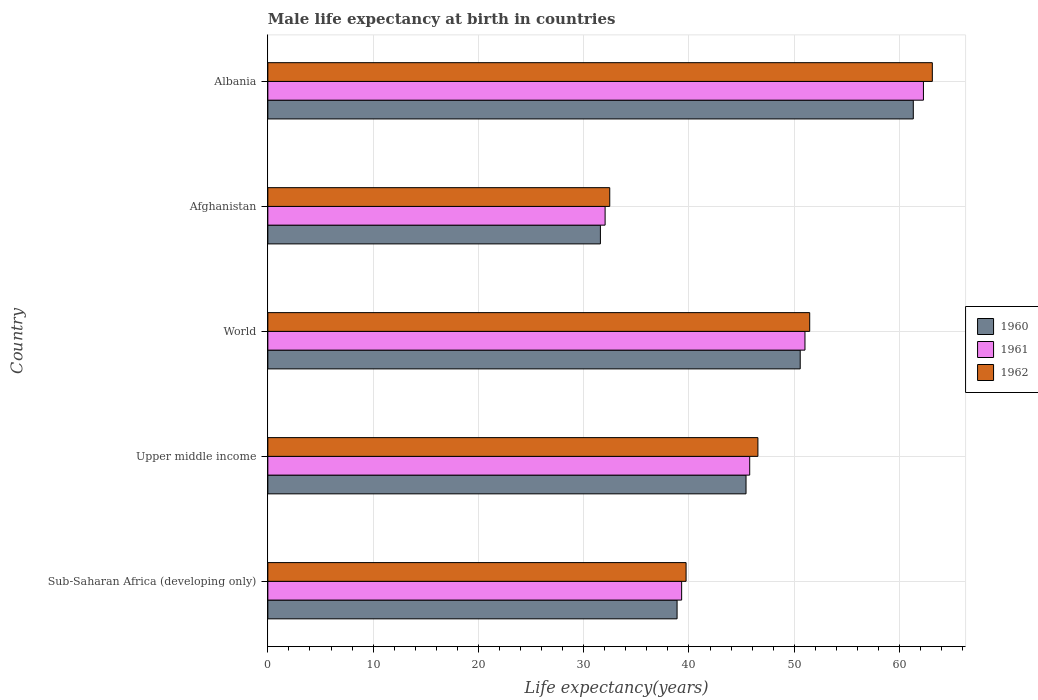How many groups of bars are there?
Your response must be concise. 5. Are the number of bars per tick equal to the number of legend labels?
Keep it short and to the point. Yes. Are the number of bars on each tick of the Y-axis equal?
Your answer should be very brief. Yes. What is the label of the 2nd group of bars from the top?
Your answer should be compact. Afghanistan. In how many cases, is the number of bars for a given country not equal to the number of legend labels?
Make the answer very short. 0. What is the male life expectancy at birth in 1962 in World?
Provide a short and direct response. 51.47. Across all countries, what is the maximum male life expectancy at birth in 1962?
Provide a succinct answer. 63.12. Across all countries, what is the minimum male life expectancy at birth in 1962?
Offer a very short reply. 32.48. In which country was the male life expectancy at birth in 1960 maximum?
Offer a terse response. Albania. In which country was the male life expectancy at birth in 1961 minimum?
Offer a terse response. Afghanistan. What is the total male life expectancy at birth in 1961 in the graph?
Make the answer very short. 230.4. What is the difference between the male life expectancy at birth in 1962 in Afghanistan and that in Upper middle income?
Keep it short and to the point. -14.07. What is the difference between the male life expectancy at birth in 1960 in Albania and the male life expectancy at birth in 1961 in Sub-Saharan Africa (developing only)?
Your response must be concise. 22. What is the average male life expectancy at birth in 1960 per country?
Your response must be concise. 45.55. What is the difference between the male life expectancy at birth in 1961 and male life expectancy at birth in 1962 in World?
Ensure brevity in your answer.  -0.45. In how many countries, is the male life expectancy at birth in 1961 greater than 22 years?
Ensure brevity in your answer.  5. What is the ratio of the male life expectancy at birth in 1962 in Afghanistan to that in World?
Give a very brief answer. 0.63. What is the difference between the highest and the second highest male life expectancy at birth in 1960?
Offer a terse response. 10.74. What is the difference between the highest and the lowest male life expectancy at birth in 1962?
Ensure brevity in your answer.  30.64. What does the 3rd bar from the top in World represents?
Keep it short and to the point. 1960. Are all the bars in the graph horizontal?
Your response must be concise. Yes. How many countries are there in the graph?
Make the answer very short. 5. Are the values on the major ticks of X-axis written in scientific E-notation?
Make the answer very short. No. Does the graph contain grids?
Your answer should be very brief. Yes. Where does the legend appear in the graph?
Make the answer very short. Center right. How are the legend labels stacked?
Your answer should be very brief. Vertical. What is the title of the graph?
Your response must be concise. Male life expectancy at birth in countries. Does "1980" appear as one of the legend labels in the graph?
Your response must be concise. No. What is the label or title of the X-axis?
Your answer should be very brief. Life expectancy(years). What is the Life expectancy(years) in 1960 in Sub-Saharan Africa (developing only)?
Provide a succinct answer. 38.87. What is the Life expectancy(years) of 1961 in Sub-Saharan Africa (developing only)?
Ensure brevity in your answer.  39.31. What is the Life expectancy(years) in 1962 in Sub-Saharan Africa (developing only)?
Offer a very short reply. 39.73. What is the Life expectancy(years) in 1960 in Upper middle income?
Your answer should be very brief. 45.42. What is the Life expectancy(years) of 1961 in Upper middle income?
Ensure brevity in your answer.  45.77. What is the Life expectancy(years) of 1962 in Upper middle income?
Ensure brevity in your answer.  46.55. What is the Life expectancy(years) in 1960 in World?
Your answer should be compact. 50.57. What is the Life expectancy(years) of 1961 in World?
Offer a terse response. 51.02. What is the Life expectancy(years) in 1962 in World?
Your answer should be compact. 51.47. What is the Life expectancy(years) of 1960 in Afghanistan?
Your answer should be compact. 31.59. What is the Life expectancy(years) of 1961 in Afghanistan?
Your answer should be very brief. 32.03. What is the Life expectancy(years) of 1962 in Afghanistan?
Keep it short and to the point. 32.48. What is the Life expectancy(years) of 1960 in Albania?
Give a very brief answer. 61.31. What is the Life expectancy(years) of 1961 in Albania?
Give a very brief answer. 62.27. What is the Life expectancy(years) of 1962 in Albania?
Provide a succinct answer. 63.12. Across all countries, what is the maximum Life expectancy(years) of 1960?
Your response must be concise. 61.31. Across all countries, what is the maximum Life expectancy(years) in 1961?
Your answer should be very brief. 62.27. Across all countries, what is the maximum Life expectancy(years) of 1962?
Offer a terse response. 63.12. Across all countries, what is the minimum Life expectancy(years) in 1960?
Offer a very short reply. 31.59. Across all countries, what is the minimum Life expectancy(years) in 1961?
Your response must be concise. 32.03. Across all countries, what is the minimum Life expectancy(years) in 1962?
Provide a succinct answer. 32.48. What is the total Life expectancy(years) of 1960 in the graph?
Your answer should be very brief. 227.76. What is the total Life expectancy(years) in 1961 in the graph?
Ensure brevity in your answer.  230.4. What is the total Life expectancy(years) of 1962 in the graph?
Provide a succinct answer. 233.34. What is the difference between the Life expectancy(years) in 1960 in Sub-Saharan Africa (developing only) and that in Upper middle income?
Your response must be concise. -6.55. What is the difference between the Life expectancy(years) of 1961 in Sub-Saharan Africa (developing only) and that in Upper middle income?
Your answer should be very brief. -6.47. What is the difference between the Life expectancy(years) of 1962 in Sub-Saharan Africa (developing only) and that in Upper middle income?
Make the answer very short. -6.82. What is the difference between the Life expectancy(years) of 1960 in Sub-Saharan Africa (developing only) and that in World?
Make the answer very short. -11.7. What is the difference between the Life expectancy(years) of 1961 in Sub-Saharan Africa (developing only) and that in World?
Offer a terse response. -11.71. What is the difference between the Life expectancy(years) in 1962 in Sub-Saharan Africa (developing only) and that in World?
Offer a very short reply. -11.74. What is the difference between the Life expectancy(years) in 1960 in Sub-Saharan Africa (developing only) and that in Afghanistan?
Your answer should be compact. 7.28. What is the difference between the Life expectancy(years) of 1961 in Sub-Saharan Africa (developing only) and that in Afghanistan?
Provide a succinct answer. 7.27. What is the difference between the Life expectancy(years) of 1962 in Sub-Saharan Africa (developing only) and that in Afghanistan?
Offer a terse response. 7.25. What is the difference between the Life expectancy(years) in 1960 in Sub-Saharan Africa (developing only) and that in Albania?
Ensure brevity in your answer.  -22.44. What is the difference between the Life expectancy(years) of 1961 in Sub-Saharan Africa (developing only) and that in Albania?
Your answer should be very brief. -22.97. What is the difference between the Life expectancy(years) of 1962 in Sub-Saharan Africa (developing only) and that in Albania?
Make the answer very short. -23.39. What is the difference between the Life expectancy(years) of 1960 in Upper middle income and that in World?
Ensure brevity in your answer.  -5.15. What is the difference between the Life expectancy(years) in 1961 in Upper middle income and that in World?
Your response must be concise. -5.25. What is the difference between the Life expectancy(years) in 1962 in Upper middle income and that in World?
Offer a very short reply. -4.92. What is the difference between the Life expectancy(years) of 1960 in Upper middle income and that in Afghanistan?
Offer a terse response. 13.83. What is the difference between the Life expectancy(years) in 1961 in Upper middle income and that in Afghanistan?
Offer a terse response. 13.74. What is the difference between the Life expectancy(years) in 1962 in Upper middle income and that in Afghanistan?
Your answer should be very brief. 14.07. What is the difference between the Life expectancy(years) in 1960 in Upper middle income and that in Albania?
Give a very brief answer. -15.89. What is the difference between the Life expectancy(years) of 1961 in Upper middle income and that in Albania?
Provide a succinct answer. -16.5. What is the difference between the Life expectancy(years) in 1962 in Upper middle income and that in Albania?
Offer a terse response. -16.57. What is the difference between the Life expectancy(years) in 1960 in World and that in Afghanistan?
Keep it short and to the point. 18.98. What is the difference between the Life expectancy(years) in 1961 in World and that in Afghanistan?
Provide a short and direct response. 18.98. What is the difference between the Life expectancy(years) of 1962 in World and that in Afghanistan?
Your response must be concise. 18.99. What is the difference between the Life expectancy(years) in 1960 in World and that in Albania?
Offer a terse response. -10.74. What is the difference between the Life expectancy(years) in 1961 in World and that in Albania?
Your answer should be very brief. -11.25. What is the difference between the Life expectancy(years) in 1962 in World and that in Albania?
Offer a terse response. -11.65. What is the difference between the Life expectancy(years) of 1960 in Afghanistan and that in Albania?
Provide a short and direct response. -29.72. What is the difference between the Life expectancy(years) in 1961 in Afghanistan and that in Albania?
Your answer should be very brief. -30.24. What is the difference between the Life expectancy(years) in 1962 in Afghanistan and that in Albania?
Ensure brevity in your answer.  -30.64. What is the difference between the Life expectancy(years) of 1960 in Sub-Saharan Africa (developing only) and the Life expectancy(years) of 1961 in Upper middle income?
Keep it short and to the point. -6.9. What is the difference between the Life expectancy(years) of 1960 in Sub-Saharan Africa (developing only) and the Life expectancy(years) of 1962 in Upper middle income?
Keep it short and to the point. -7.68. What is the difference between the Life expectancy(years) of 1961 in Sub-Saharan Africa (developing only) and the Life expectancy(years) of 1962 in Upper middle income?
Your response must be concise. -7.24. What is the difference between the Life expectancy(years) in 1960 in Sub-Saharan Africa (developing only) and the Life expectancy(years) in 1961 in World?
Offer a very short reply. -12.15. What is the difference between the Life expectancy(years) of 1960 in Sub-Saharan Africa (developing only) and the Life expectancy(years) of 1962 in World?
Provide a succinct answer. -12.6. What is the difference between the Life expectancy(years) in 1961 in Sub-Saharan Africa (developing only) and the Life expectancy(years) in 1962 in World?
Provide a short and direct response. -12.16. What is the difference between the Life expectancy(years) in 1960 in Sub-Saharan Africa (developing only) and the Life expectancy(years) in 1961 in Afghanistan?
Your answer should be compact. 6.84. What is the difference between the Life expectancy(years) of 1960 in Sub-Saharan Africa (developing only) and the Life expectancy(years) of 1962 in Afghanistan?
Offer a terse response. 6.4. What is the difference between the Life expectancy(years) of 1961 in Sub-Saharan Africa (developing only) and the Life expectancy(years) of 1962 in Afghanistan?
Your response must be concise. 6.83. What is the difference between the Life expectancy(years) of 1960 in Sub-Saharan Africa (developing only) and the Life expectancy(years) of 1961 in Albania?
Provide a succinct answer. -23.4. What is the difference between the Life expectancy(years) of 1960 in Sub-Saharan Africa (developing only) and the Life expectancy(years) of 1962 in Albania?
Your response must be concise. -24.25. What is the difference between the Life expectancy(years) in 1961 in Sub-Saharan Africa (developing only) and the Life expectancy(years) in 1962 in Albania?
Your answer should be compact. -23.81. What is the difference between the Life expectancy(years) of 1960 in Upper middle income and the Life expectancy(years) of 1961 in World?
Provide a succinct answer. -5.6. What is the difference between the Life expectancy(years) in 1960 in Upper middle income and the Life expectancy(years) in 1962 in World?
Your response must be concise. -6.05. What is the difference between the Life expectancy(years) of 1961 in Upper middle income and the Life expectancy(years) of 1962 in World?
Keep it short and to the point. -5.7. What is the difference between the Life expectancy(years) in 1960 in Upper middle income and the Life expectancy(years) in 1961 in Afghanistan?
Offer a terse response. 13.39. What is the difference between the Life expectancy(years) in 1960 in Upper middle income and the Life expectancy(years) in 1962 in Afghanistan?
Ensure brevity in your answer.  12.94. What is the difference between the Life expectancy(years) of 1961 in Upper middle income and the Life expectancy(years) of 1962 in Afghanistan?
Offer a terse response. 13.29. What is the difference between the Life expectancy(years) of 1960 in Upper middle income and the Life expectancy(years) of 1961 in Albania?
Ensure brevity in your answer.  -16.85. What is the difference between the Life expectancy(years) in 1960 in Upper middle income and the Life expectancy(years) in 1962 in Albania?
Your response must be concise. -17.7. What is the difference between the Life expectancy(years) in 1961 in Upper middle income and the Life expectancy(years) in 1962 in Albania?
Your answer should be compact. -17.35. What is the difference between the Life expectancy(years) of 1960 in World and the Life expectancy(years) of 1961 in Afghanistan?
Provide a short and direct response. 18.53. What is the difference between the Life expectancy(years) of 1960 in World and the Life expectancy(years) of 1962 in Afghanistan?
Give a very brief answer. 18.09. What is the difference between the Life expectancy(years) of 1961 in World and the Life expectancy(years) of 1962 in Afghanistan?
Your answer should be very brief. 18.54. What is the difference between the Life expectancy(years) in 1960 in World and the Life expectancy(years) in 1961 in Albania?
Keep it short and to the point. -11.7. What is the difference between the Life expectancy(years) of 1960 in World and the Life expectancy(years) of 1962 in Albania?
Give a very brief answer. -12.55. What is the difference between the Life expectancy(years) in 1961 in World and the Life expectancy(years) in 1962 in Albania?
Your answer should be compact. -12.1. What is the difference between the Life expectancy(years) in 1960 in Afghanistan and the Life expectancy(years) in 1961 in Albania?
Offer a very short reply. -30.68. What is the difference between the Life expectancy(years) in 1960 in Afghanistan and the Life expectancy(years) in 1962 in Albania?
Provide a succinct answer. -31.53. What is the difference between the Life expectancy(years) in 1961 in Afghanistan and the Life expectancy(years) in 1962 in Albania?
Your answer should be compact. -31.08. What is the average Life expectancy(years) of 1960 per country?
Your answer should be compact. 45.55. What is the average Life expectancy(years) of 1961 per country?
Offer a very short reply. 46.08. What is the average Life expectancy(years) of 1962 per country?
Provide a succinct answer. 46.67. What is the difference between the Life expectancy(years) in 1960 and Life expectancy(years) in 1961 in Sub-Saharan Africa (developing only)?
Keep it short and to the point. -0.43. What is the difference between the Life expectancy(years) in 1960 and Life expectancy(years) in 1962 in Sub-Saharan Africa (developing only)?
Your response must be concise. -0.86. What is the difference between the Life expectancy(years) in 1961 and Life expectancy(years) in 1962 in Sub-Saharan Africa (developing only)?
Your answer should be compact. -0.42. What is the difference between the Life expectancy(years) of 1960 and Life expectancy(years) of 1961 in Upper middle income?
Your answer should be very brief. -0.35. What is the difference between the Life expectancy(years) of 1960 and Life expectancy(years) of 1962 in Upper middle income?
Offer a very short reply. -1.13. What is the difference between the Life expectancy(years) in 1961 and Life expectancy(years) in 1962 in Upper middle income?
Keep it short and to the point. -0.78. What is the difference between the Life expectancy(years) in 1960 and Life expectancy(years) in 1961 in World?
Provide a short and direct response. -0.45. What is the difference between the Life expectancy(years) in 1960 and Life expectancy(years) in 1962 in World?
Your answer should be very brief. -0.9. What is the difference between the Life expectancy(years) of 1961 and Life expectancy(years) of 1962 in World?
Your answer should be very brief. -0.45. What is the difference between the Life expectancy(years) in 1960 and Life expectancy(years) in 1961 in Afghanistan?
Keep it short and to the point. -0.45. What is the difference between the Life expectancy(years) in 1960 and Life expectancy(years) in 1962 in Afghanistan?
Keep it short and to the point. -0.89. What is the difference between the Life expectancy(years) of 1961 and Life expectancy(years) of 1962 in Afghanistan?
Ensure brevity in your answer.  -0.44. What is the difference between the Life expectancy(years) in 1960 and Life expectancy(years) in 1961 in Albania?
Provide a succinct answer. -0.96. What is the difference between the Life expectancy(years) of 1960 and Life expectancy(years) of 1962 in Albania?
Give a very brief answer. -1.81. What is the difference between the Life expectancy(years) of 1961 and Life expectancy(years) of 1962 in Albania?
Keep it short and to the point. -0.84. What is the ratio of the Life expectancy(years) in 1960 in Sub-Saharan Africa (developing only) to that in Upper middle income?
Your answer should be very brief. 0.86. What is the ratio of the Life expectancy(years) in 1961 in Sub-Saharan Africa (developing only) to that in Upper middle income?
Your answer should be very brief. 0.86. What is the ratio of the Life expectancy(years) of 1962 in Sub-Saharan Africa (developing only) to that in Upper middle income?
Provide a succinct answer. 0.85. What is the ratio of the Life expectancy(years) of 1960 in Sub-Saharan Africa (developing only) to that in World?
Provide a short and direct response. 0.77. What is the ratio of the Life expectancy(years) in 1961 in Sub-Saharan Africa (developing only) to that in World?
Provide a short and direct response. 0.77. What is the ratio of the Life expectancy(years) of 1962 in Sub-Saharan Africa (developing only) to that in World?
Ensure brevity in your answer.  0.77. What is the ratio of the Life expectancy(years) in 1960 in Sub-Saharan Africa (developing only) to that in Afghanistan?
Give a very brief answer. 1.23. What is the ratio of the Life expectancy(years) in 1961 in Sub-Saharan Africa (developing only) to that in Afghanistan?
Give a very brief answer. 1.23. What is the ratio of the Life expectancy(years) of 1962 in Sub-Saharan Africa (developing only) to that in Afghanistan?
Give a very brief answer. 1.22. What is the ratio of the Life expectancy(years) of 1960 in Sub-Saharan Africa (developing only) to that in Albania?
Offer a terse response. 0.63. What is the ratio of the Life expectancy(years) of 1961 in Sub-Saharan Africa (developing only) to that in Albania?
Offer a terse response. 0.63. What is the ratio of the Life expectancy(years) of 1962 in Sub-Saharan Africa (developing only) to that in Albania?
Give a very brief answer. 0.63. What is the ratio of the Life expectancy(years) in 1960 in Upper middle income to that in World?
Offer a very short reply. 0.9. What is the ratio of the Life expectancy(years) of 1961 in Upper middle income to that in World?
Your answer should be very brief. 0.9. What is the ratio of the Life expectancy(years) in 1962 in Upper middle income to that in World?
Offer a very short reply. 0.9. What is the ratio of the Life expectancy(years) of 1960 in Upper middle income to that in Afghanistan?
Offer a very short reply. 1.44. What is the ratio of the Life expectancy(years) of 1961 in Upper middle income to that in Afghanistan?
Provide a short and direct response. 1.43. What is the ratio of the Life expectancy(years) in 1962 in Upper middle income to that in Afghanistan?
Provide a short and direct response. 1.43. What is the ratio of the Life expectancy(years) in 1960 in Upper middle income to that in Albania?
Provide a short and direct response. 0.74. What is the ratio of the Life expectancy(years) in 1961 in Upper middle income to that in Albania?
Your answer should be very brief. 0.73. What is the ratio of the Life expectancy(years) of 1962 in Upper middle income to that in Albania?
Your response must be concise. 0.74. What is the ratio of the Life expectancy(years) of 1960 in World to that in Afghanistan?
Ensure brevity in your answer.  1.6. What is the ratio of the Life expectancy(years) of 1961 in World to that in Afghanistan?
Your response must be concise. 1.59. What is the ratio of the Life expectancy(years) in 1962 in World to that in Afghanistan?
Your response must be concise. 1.58. What is the ratio of the Life expectancy(years) of 1960 in World to that in Albania?
Provide a short and direct response. 0.82. What is the ratio of the Life expectancy(years) of 1961 in World to that in Albania?
Offer a very short reply. 0.82. What is the ratio of the Life expectancy(years) in 1962 in World to that in Albania?
Keep it short and to the point. 0.82. What is the ratio of the Life expectancy(years) in 1960 in Afghanistan to that in Albania?
Keep it short and to the point. 0.52. What is the ratio of the Life expectancy(years) of 1961 in Afghanistan to that in Albania?
Keep it short and to the point. 0.51. What is the ratio of the Life expectancy(years) of 1962 in Afghanistan to that in Albania?
Keep it short and to the point. 0.51. What is the difference between the highest and the second highest Life expectancy(years) of 1960?
Keep it short and to the point. 10.74. What is the difference between the highest and the second highest Life expectancy(years) in 1961?
Offer a very short reply. 11.25. What is the difference between the highest and the second highest Life expectancy(years) in 1962?
Your answer should be compact. 11.65. What is the difference between the highest and the lowest Life expectancy(years) in 1960?
Your answer should be compact. 29.72. What is the difference between the highest and the lowest Life expectancy(years) of 1961?
Your response must be concise. 30.24. What is the difference between the highest and the lowest Life expectancy(years) of 1962?
Your answer should be compact. 30.64. 